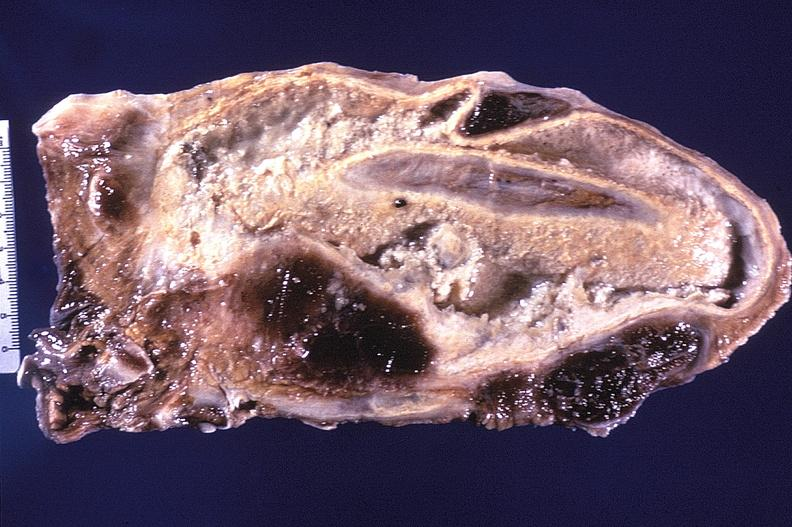does this image show tuberculosis, empyema?
Answer the question using a single word or phrase. Yes 